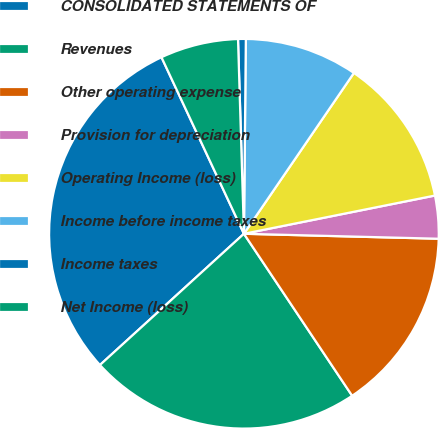<chart> <loc_0><loc_0><loc_500><loc_500><pie_chart><fcel>CONSOLIDATED STATEMENTS OF<fcel>Revenues<fcel>Other operating expense<fcel>Provision for depreciation<fcel>Operating Income (loss)<fcel>Income before income taxes<fcel>Income taxes<fcel>Net Income (loss)<nl><fcel>29.81%<fcel>22.61%<fcel>15.22%<fcel>3.55%<fcel>12.31%<fcel>9.39%<fcel>0.64%<fcel>6.47%<nl></chart> 